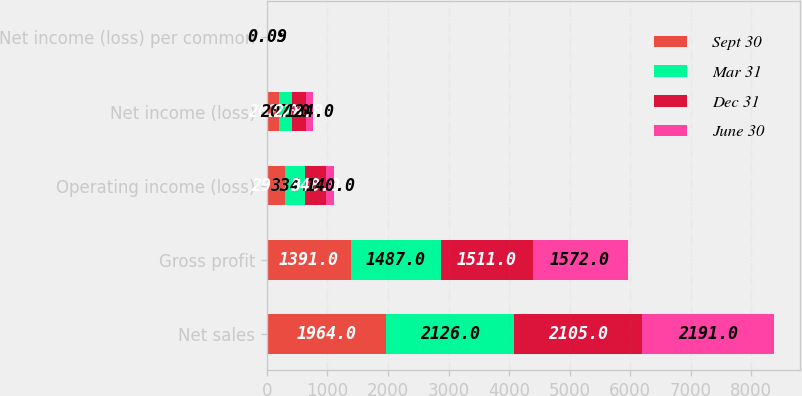Convert chart. <chart><loc_0><loc_0><loc_500><loc_500><stacked_bar_chart><ecel><fcel>Net sales<fcel>Gross profit<fcel>Operating income (loss)<fcel>Net income (loss)<fcel>Net income (loss) per common<nl><fcel>Sept 30<fcel>1964<fcel>1391<fcel>293<fcel>202<fcel>0.15<nl><fcel>Mar 31<fcel>2126<fcel>1487<fcel>334<fcel>207<fcel>0.15<nl><fcel>Dec 31<fcel>2105<fcel>1511<fcel>348<fcel>228<fcel>0.17<nl><fcel>June 30<fcel>2191<fcel>1572<fcel>140<fcel>124<fcel>0.09<nl></chart> 